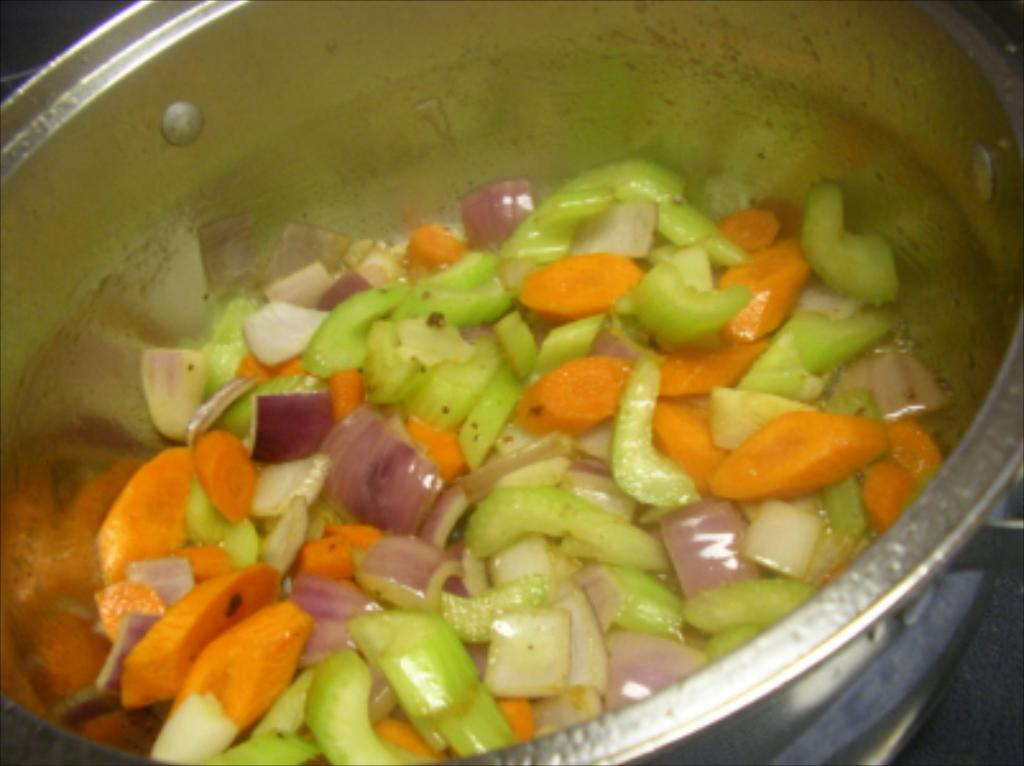What is in the bowl that is visible in the image? There is some food in the bowl in the image. How does the food in the bowl twist in the image? The food in the bowl does not twist in the image; it is stationary in the bowl. What is the wish of the food in the bowl in the image? There is no indication in the image that the food has a wish, as food does not have the ability to express wishes. 